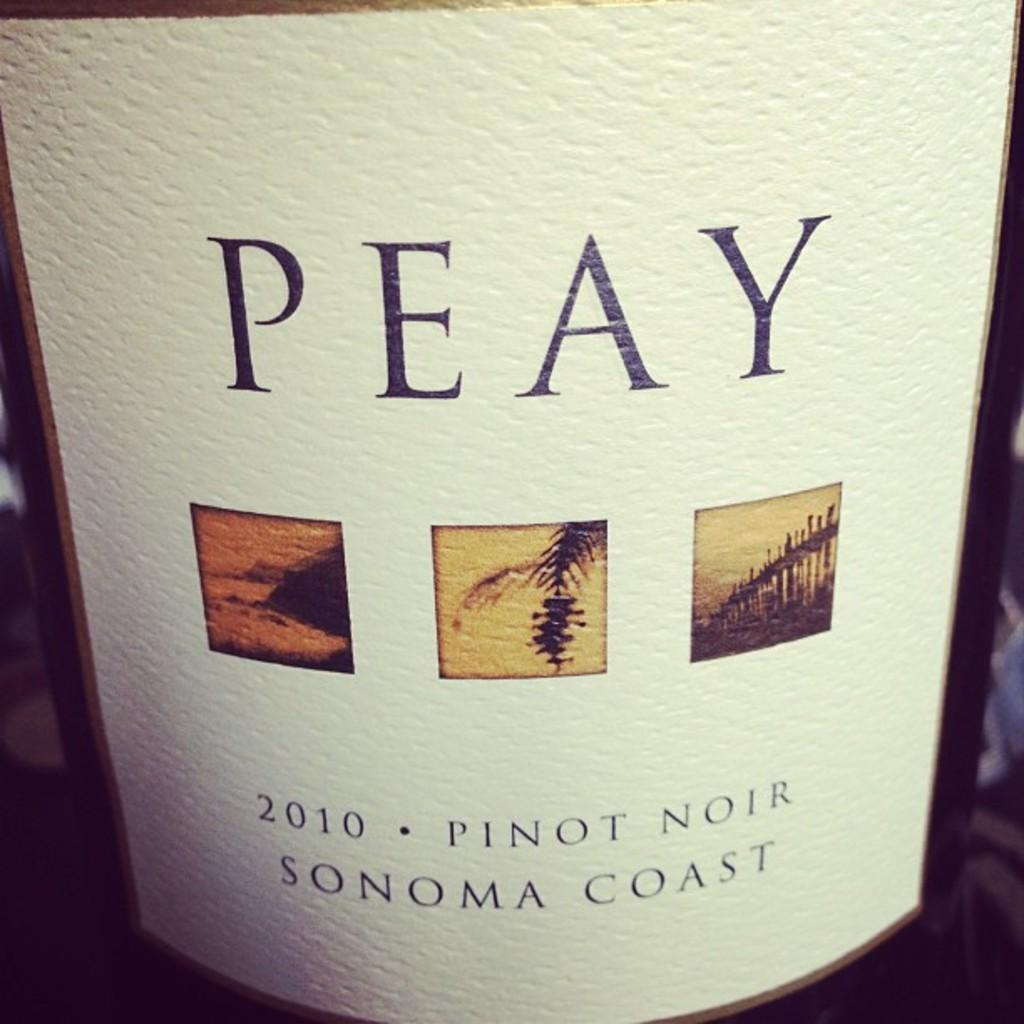<image>
Summarize the visual content of the image. Bottle of Peay wine Pinot Noir Sonoma Coast of 2010. 